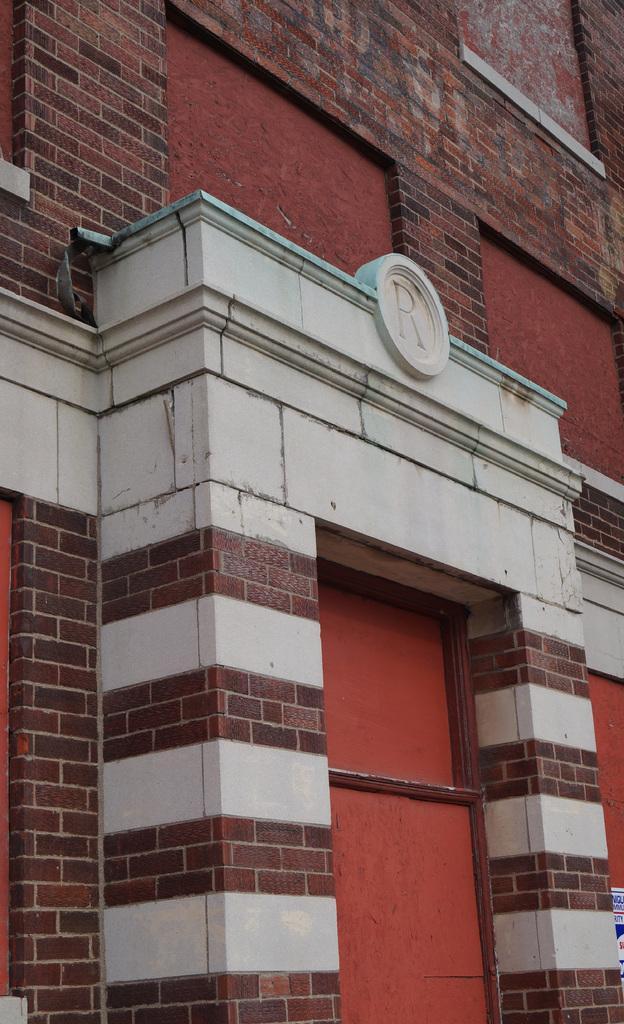Could you give a brief overview of what you see in this image? This is a picture of an arc of a building. 